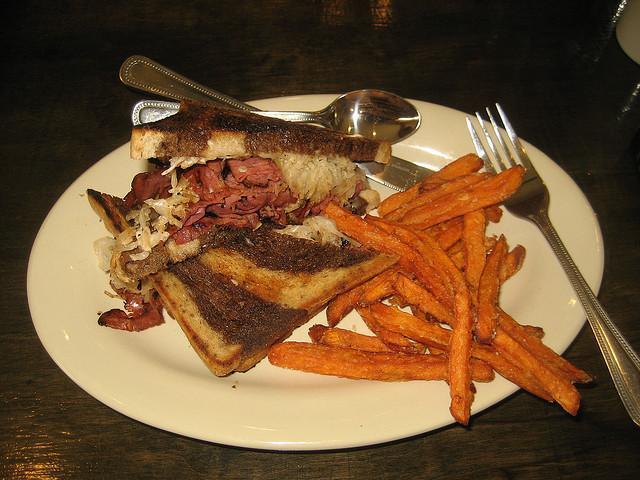How many pieces of silverware are present?
Give a very brief answer. 3. 